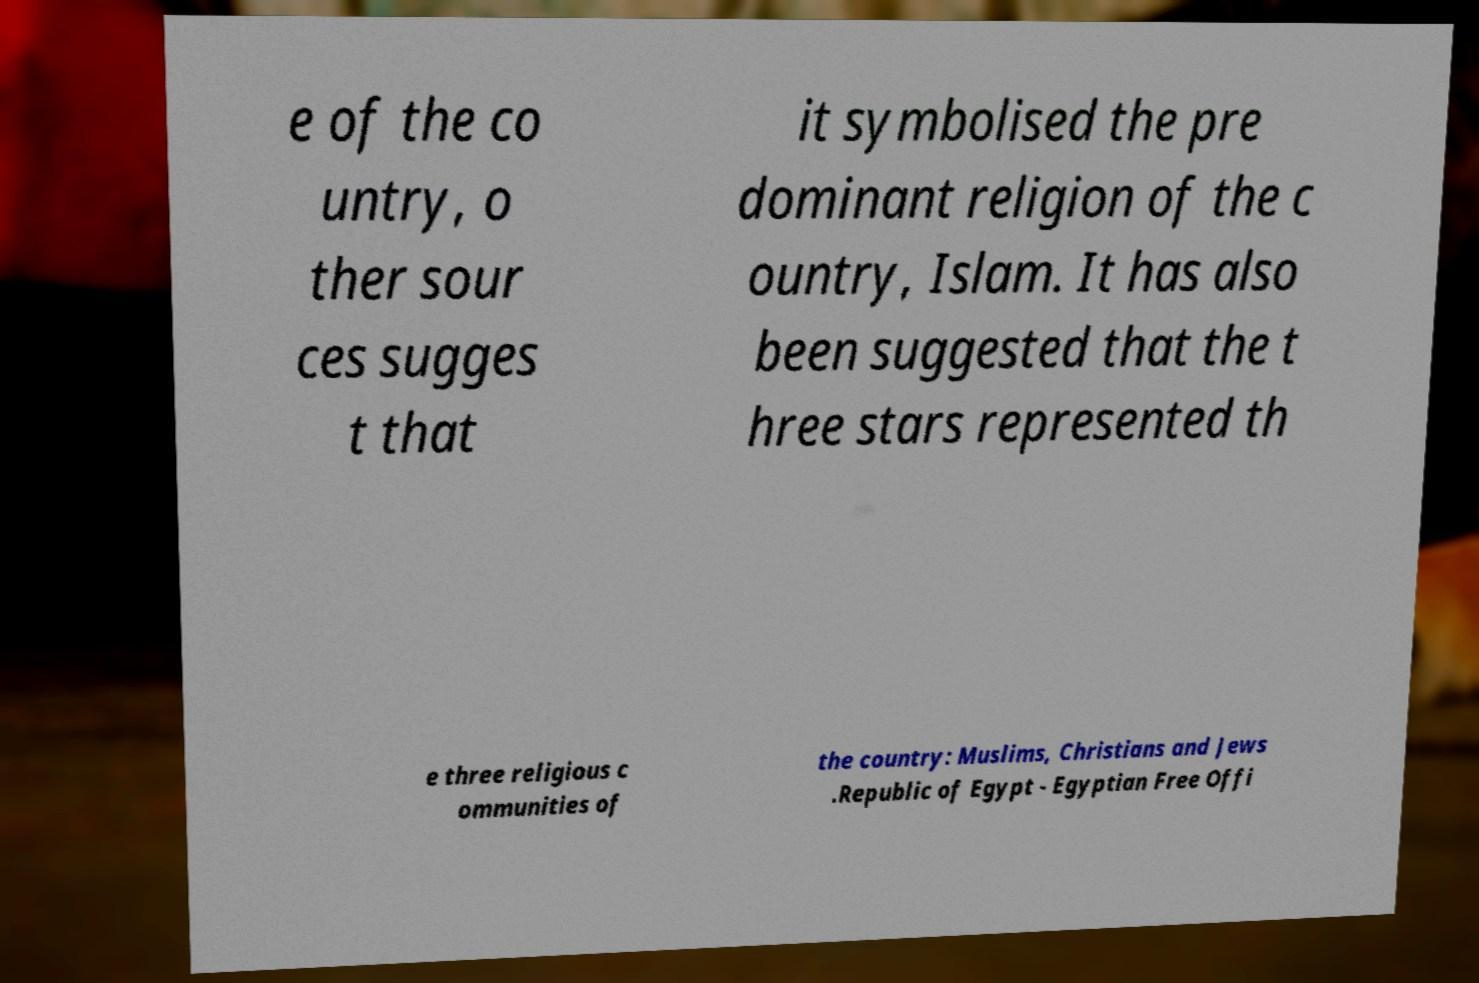Could you extract and type out the text from this image? e of the co untry, o ther sour ces sugges t that it symbolised the pre dominant religion of the c ountry, Islam. It has also been suggested that the t hree stars represented th e three religious c ommunities of the country: Muslims, Christians and Jews .Republic of Egypt - Egyptian Free Offi 